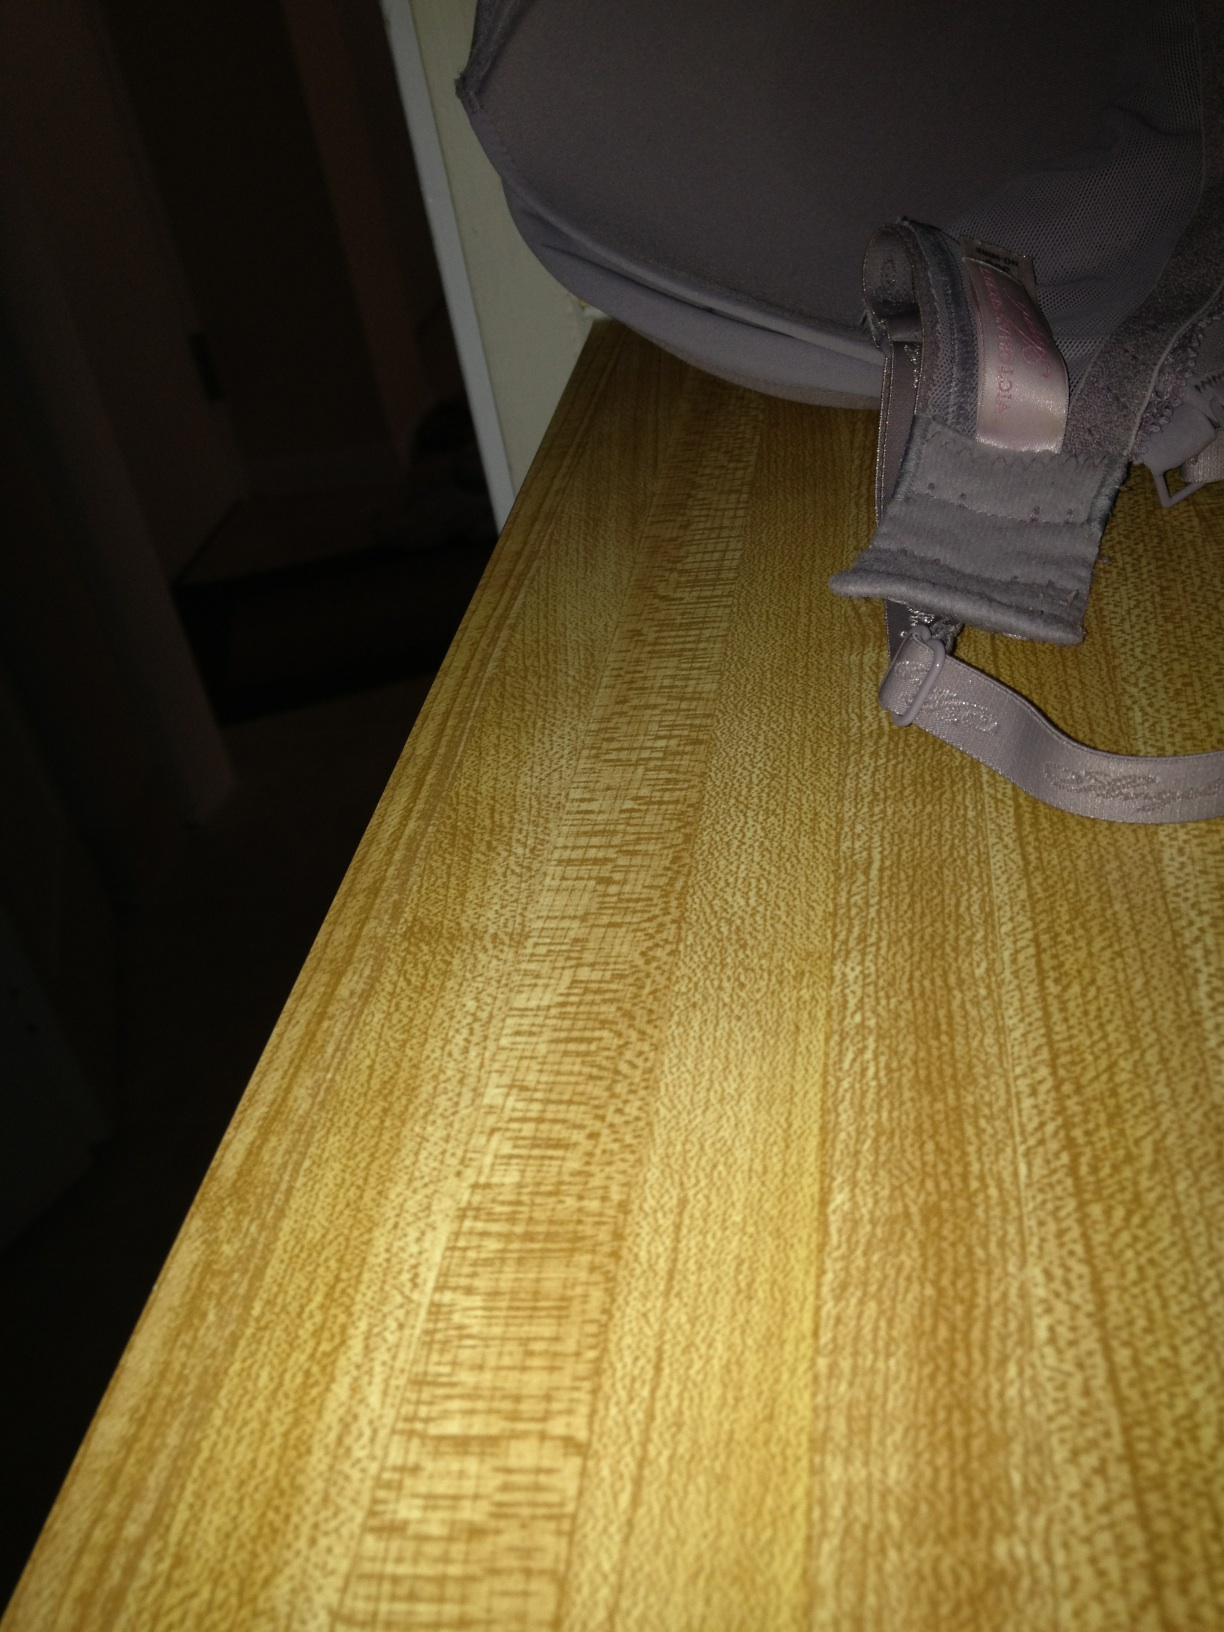Who makes this undergarment? The undergarment in the image is difficult to identify by brand from this angle without visible logos or labels. Inspecting any tags or markings on the garment itself typically offers the best clue for determining its manufacturer. 